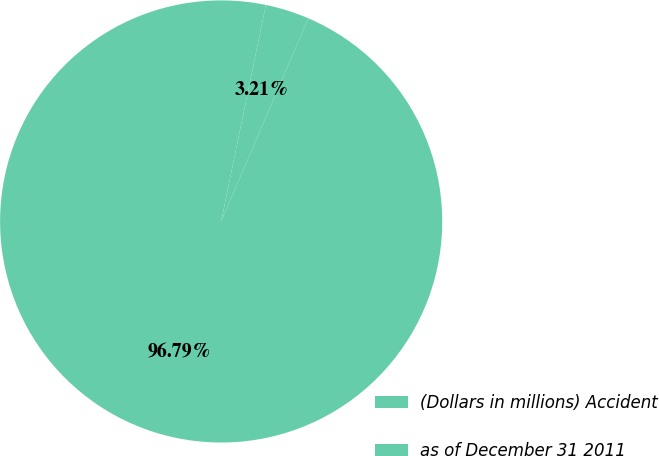<chart> <loc_0><loc_0><loc_500><loc_500><pie_chart><fcel>(Dollars in millions) Accident<fcel>as of December 31 2011<nl><fcel>96.79%<fcel>3.21%<nl></chart> 